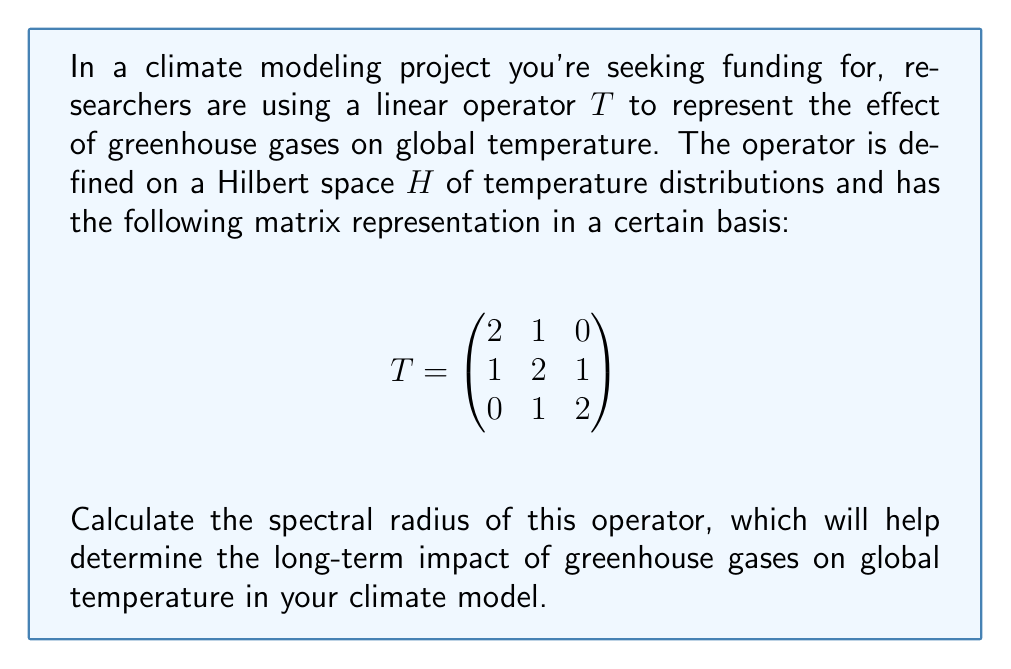Provide a solution to this math problem. To calculate the spectral radius of the linear operator $T$, we follow these steps:

1) The spectral radius $\rho(T)$ is defined as:
   $$\rho(T) = \max\{|\lambda| : \lambda \text{ is an eigenvalue of } T\}$$

2) To find the eigenvalues, we solve the characteristic equation:
   $$\det(T - \lambda I) = 0$$

3) Expand the determinant:
   $$\begin{vmatrix}
   2-\lambda & 1 & 0 \\
   1 & 2-\lambda & 1 \\
   0 & 1 & 2-\lambda
   \end{vmatrix} = 0$$

4) This gives us the characteristic polynomial:
   $$(2-\lambda)^3 - 2(2-\lambda) - 1 = 0$$

5) Simplify:
   $$\lambda^3 - 6\lambda^2 + 10\lambda - 4 = 0$$

6) This cubic equation can be solved using the cubic formula or numerical methods. The roots are:
   $$\lambda_1 = 4, \lambda_2 = 1, \lambda_3 = 1$$

7) The spectral radius is the maximum absolute value of these eigenvalues:
   $$\rho(T) = \max\{|4|, |1|, |1|\} = 4$$

Therefore, the spectral radius of the operator $T$ is 4.
Answer: $\rho(T) = 4$ 